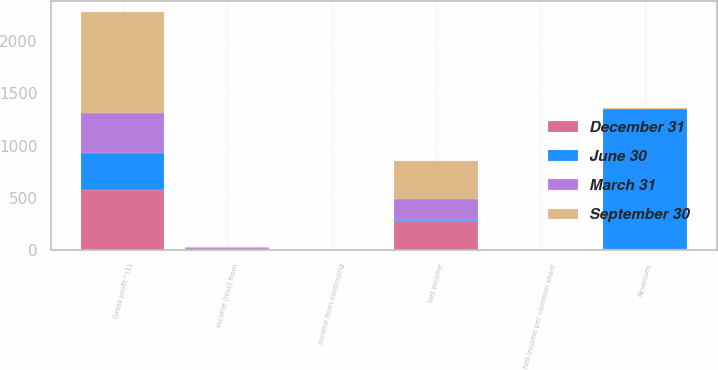<chart> <loc_0><loc_0><loc_500><loc_500><stacked_bar_chart><ecel><fcel>Revenues<fcel>Gross profit^(1)<fcel>Income from continuing<fcel>Income (loss) from<fcel>Net income<fcel>Net income per common share<nl><fcel>September 30<fcel>6<fcel>962<fcel>0.8<fcel>6<fcel>370<fcel>0.82<nl><fcel>December 31<fcel>6<fcel>571<fcel>0.61<fcel>2<fcel>277<fcel>0.61<nl><fcel>March 31<fcel>6<fcel>384<fcel>0.39<fcel>19<fcel>196<fcel>0.43<nl><fcel>June 30<fcel>1342<fcel>359<fcel>0.02<fcel>1<fcel>10<fcel>0.02<nl></chart> 